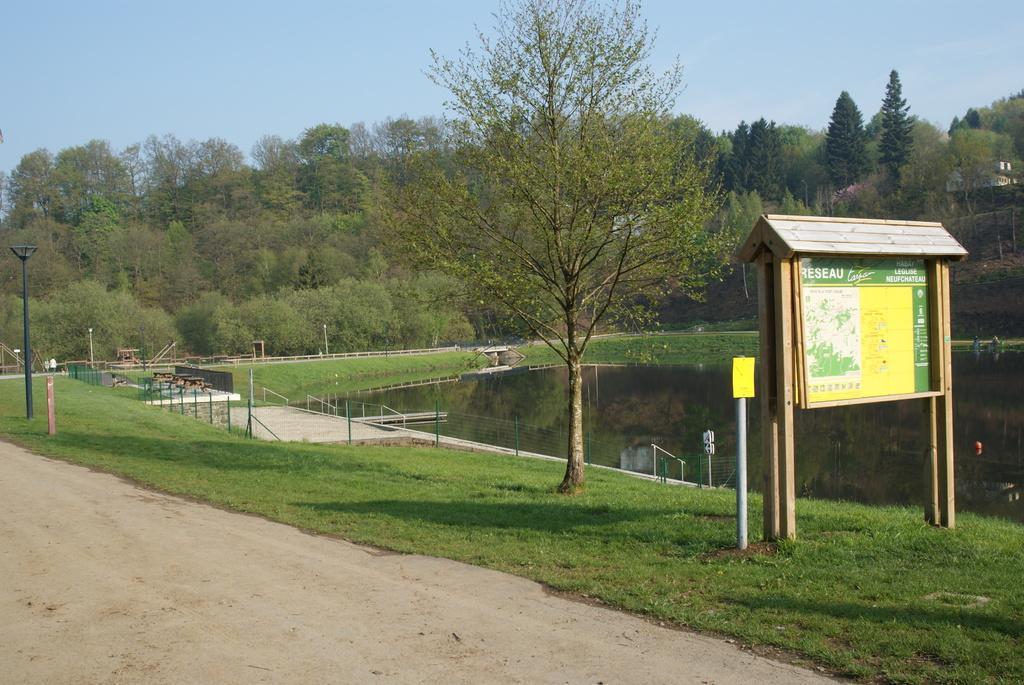Please provide a concise description of this image. In this picture we can observe a road. There is some grass on the ground. We can observe a small pond. On the right side there is a board which is in yellow and green color. In the background there are some trees and a sky. 